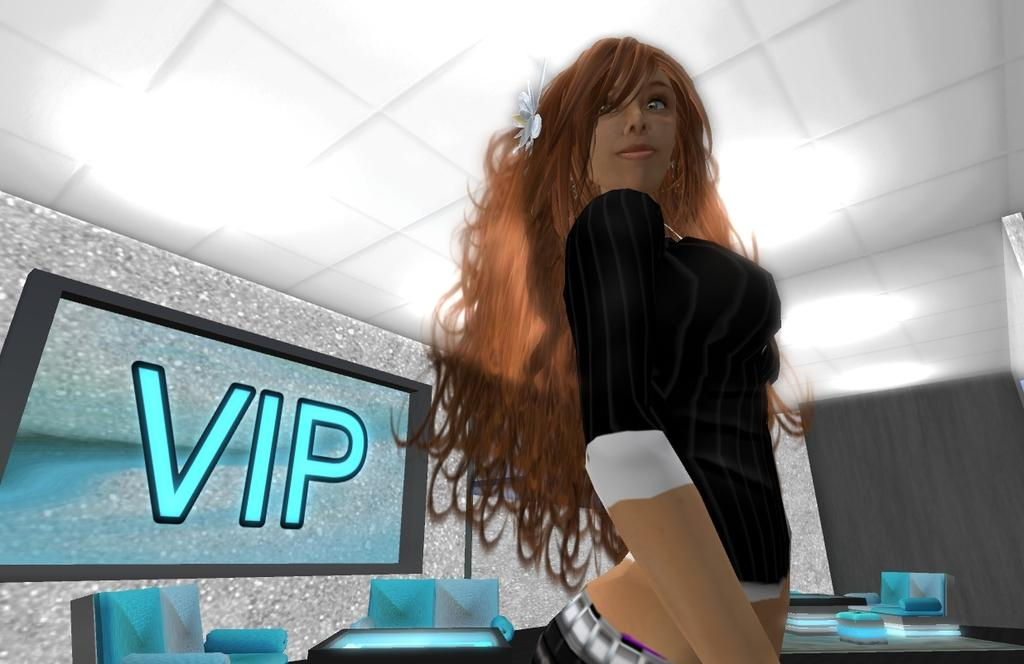What type of image is being described? The image is animated. Can you describe the characters or subjects in the image? There is a girl in the image. What objects can be seen in the image? There is a television, a wall, chairs, tables, and a ceiling in the image. What is on the television screen? Something is written on the screen. How many objects are present in the image? There are multiple objects in the image, including a television, a wall, chairs, tables, and a ceiling. What type of apparel is the girl wearing in the image? The provided facts do not mention any specific apparel worn by the girl in the image. Can you describe the grass in the image? There is no grass present in the image; it is an indoor scene with a television, a wall, chairs, tables, and a ceiling. 